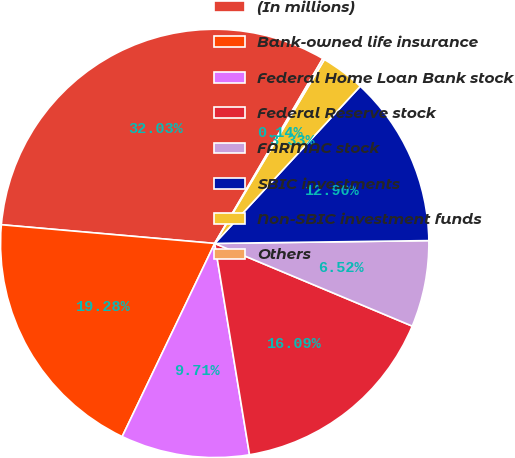Convert chart. <chart><loc_0><loc_0><loc_500><loc_500><pie_chart><fcel>(In millions)<fcel>Bank-owned life insurance<fcel>Federal Home Loan Bank stock<fcel>Federal Reserve stock<fcel>FARMAC stock<fcel>SBIC investments<fcel>Non-SBIC investment funds<fcel>Others<nl><fcel>32.03%<fcel>19.28%<fcel>9.71%<fcel>16.09%<fcel>6.52%<fcel>12.9%<fcel>3.33%<fcel>0.14%<nl></chart> 